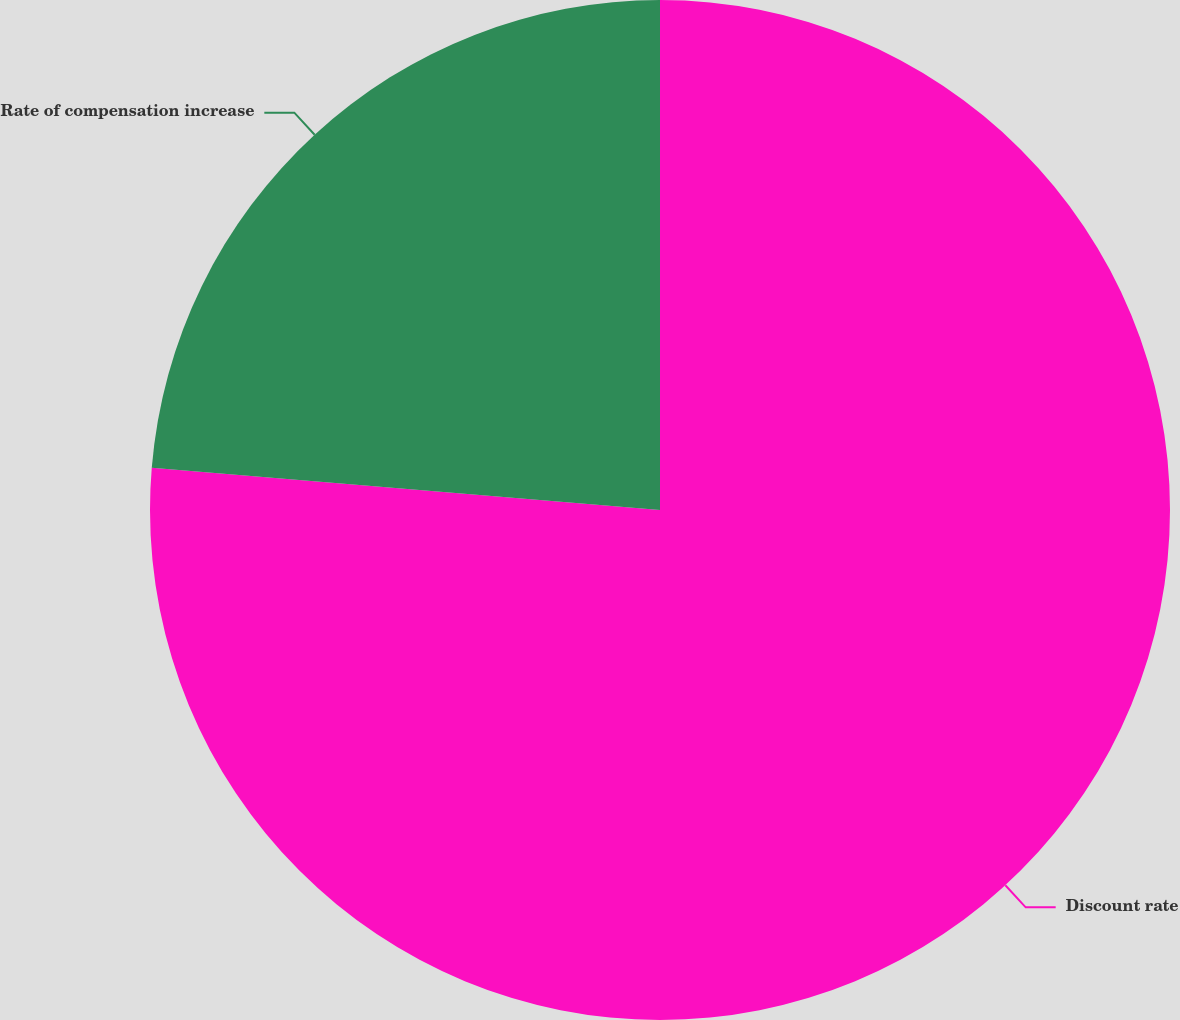Convert chart to OTSL. <chart><loc_0><loc_0><loc_500><loc_500><pie_chart><fcel>Discount rate<fcel>Rate of compensation increase<nl><fcel>76.32%<fcel>23.68%<nl></chart> 